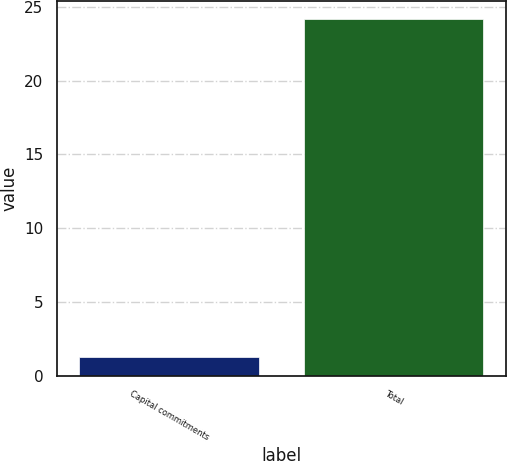Convert chart. <chart><loc_0><loc_0><loc_500><loc_500><bar_chart><fcel>Capital commitments<fcel>Total<nl><fcel>1.3<fcel>24.2<nl></chart> 